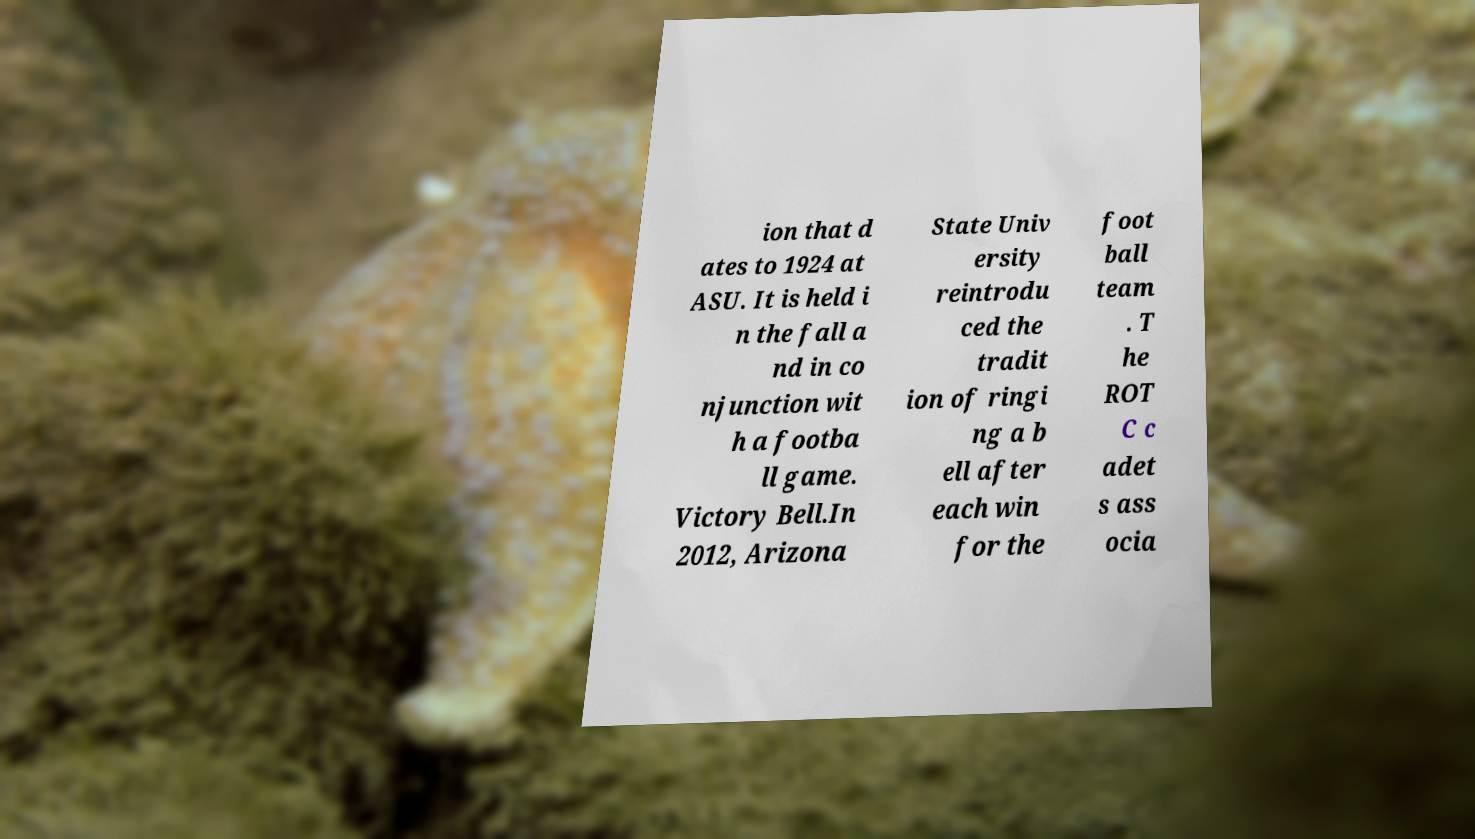I need the written content from this picture converted into text. Can you do that? ion that d ates to 1924 at ASU. It is held i n the fall a nd in co njunction wit h a footba ll game. Victory Bell.In 2012, Arizona State Univ ersity reintrodu ced the tradit ion of ringi ng a b ell after each win for the foot ball team . T he ROT C c adet s ass ocia 